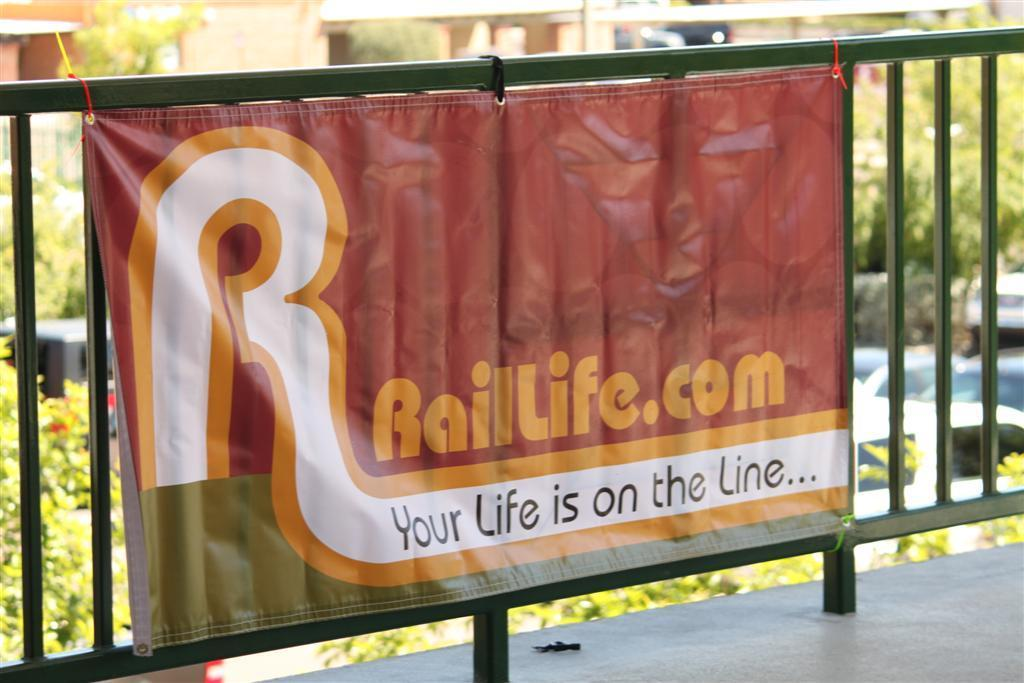Provide a one-sentence caption for the provided image. A banner with a slogan of "Your Life is on the Line" hangs from a metal fence. 